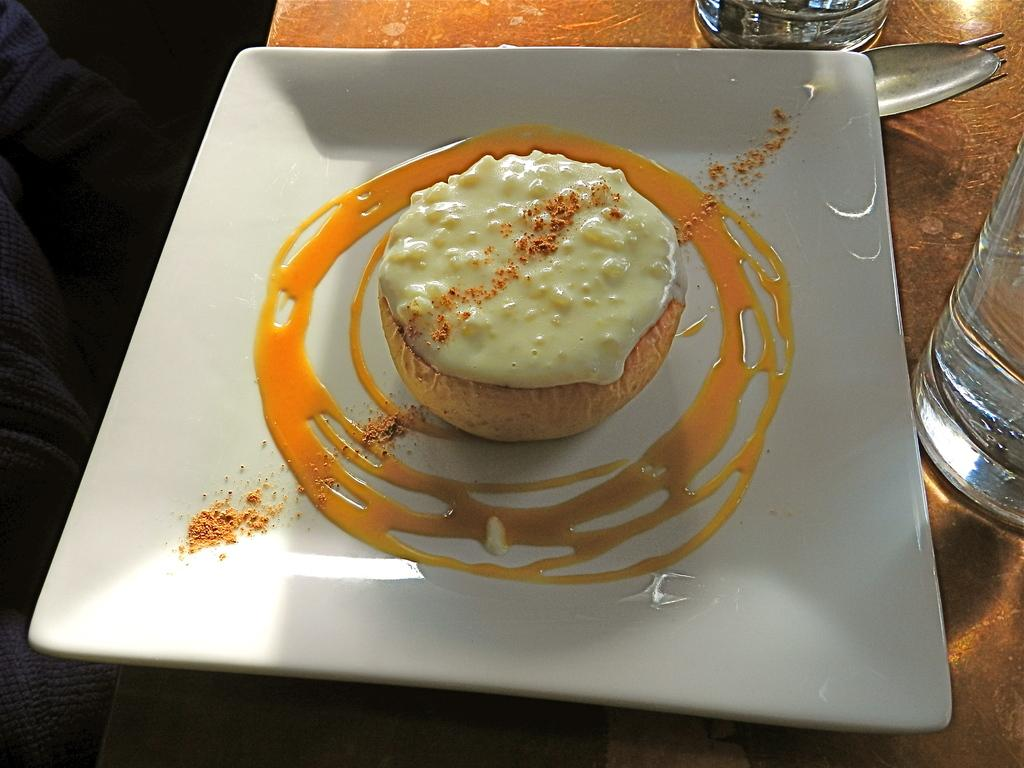What type of food is featured in the image? There is a dessert in the image. How is the dessert presented? The dessert has a sauce dressing around it. What is the dessert placed on? The dessert is placed on a white plate. What type of boat is visible in the image? There is no boat present in the image; it features a dessert with a sauce dressing on a white plate. 